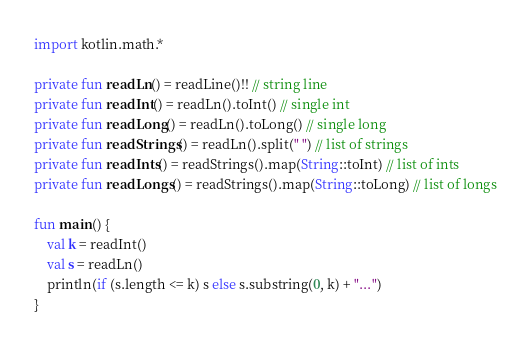Convert code to text. <code><loc_0><loc_0><loc_500><loc_500><_Kotlin_>import kotlin.math.*

private fun readLn() = readLine()!! // string line
private fun readInt() = readLn().toInt() // single int
private fun readLong() = readLn().toLong() // single long
private fun readStrings() = readLn().split(" ") // list of strings
private fun readInts() = readStrings().map(String::toInt) // list of ints
private fun readLongs() = readStrings().map(String::toLong) // list of longs

fun main() {
    val k = readInt()
    val s = readLn()
    println(if (s.length <= k) s else s.substring(0, k) + "...")
}
</code> 